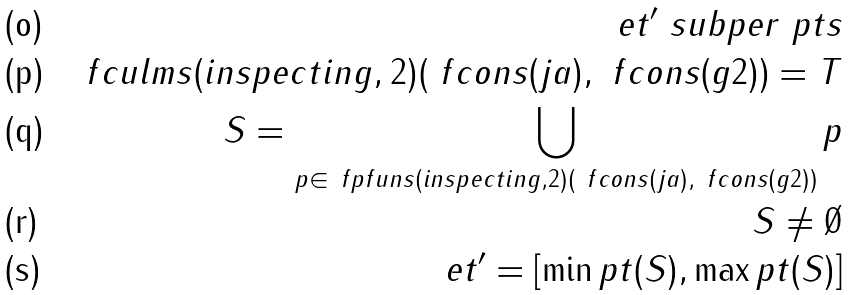<formula> <loc_0><loc_0><loc_500><loc_500>e t ^ { \prime } \ s u b p e r \ p t s \\ \ f c u l m s ( i n s p e c t i n g , 2 ) ( \ f c o n s ( j a ) , \ f c o n s ( g 2 ) ) = T \\ S = \bigcup _ { p \in \ f p f u n s ( i n s p e c t i n g , 2 ) ( \ f c o n s ( j a ) , \ f c o n s ( g 2 ) ) } p \\ S \not = \emptyset \\ e t ^ { \prime } = [ \min p t ( S ) , \max p t ( S ) ]</formula> 